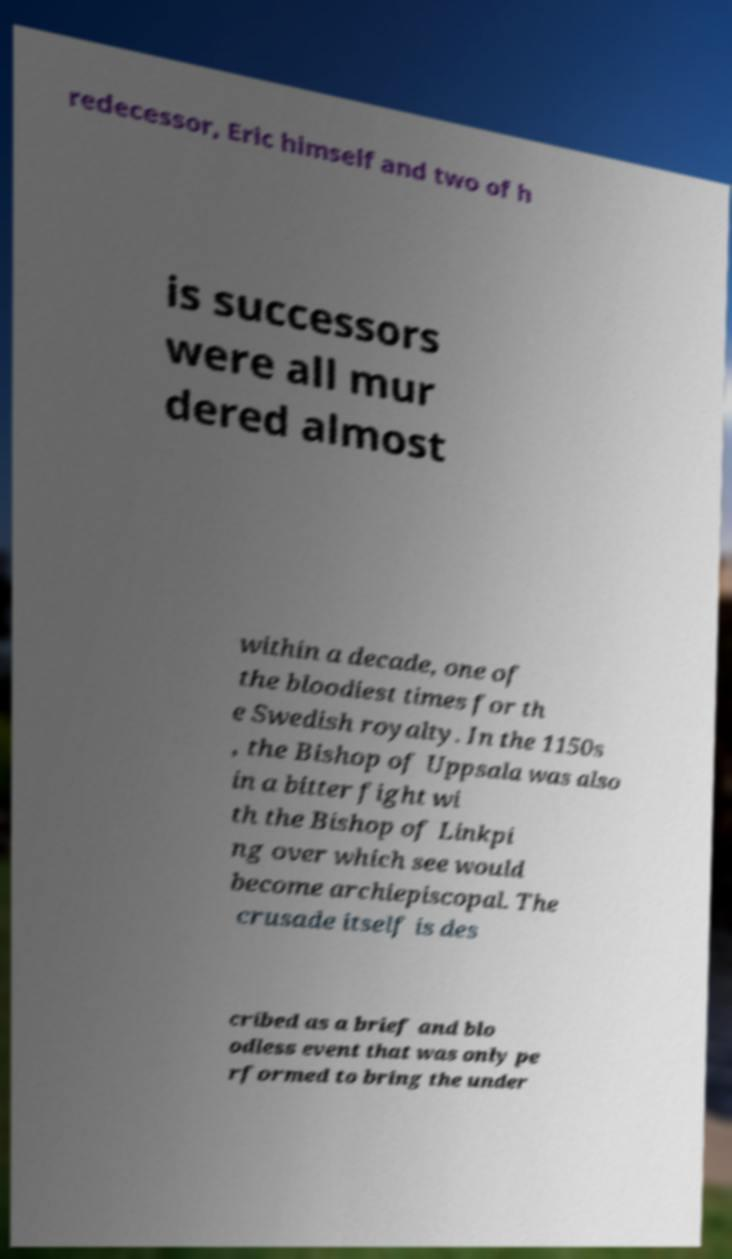Can you accurately transcribe the text from the provided image for me? redecessor, Eric himself and two of h is successors were all mur dered almost within a decade, one of the bloodiest times for th e Swedish royalty. In the 1150s , the Bishop of Uppsala was also in a bitter fight wi th the Bishop of Linkpi ng over which see would become archiepiscopal. The crusade itself is des cribed as a brief and blo odless event that was only pe rformed to bring the under 